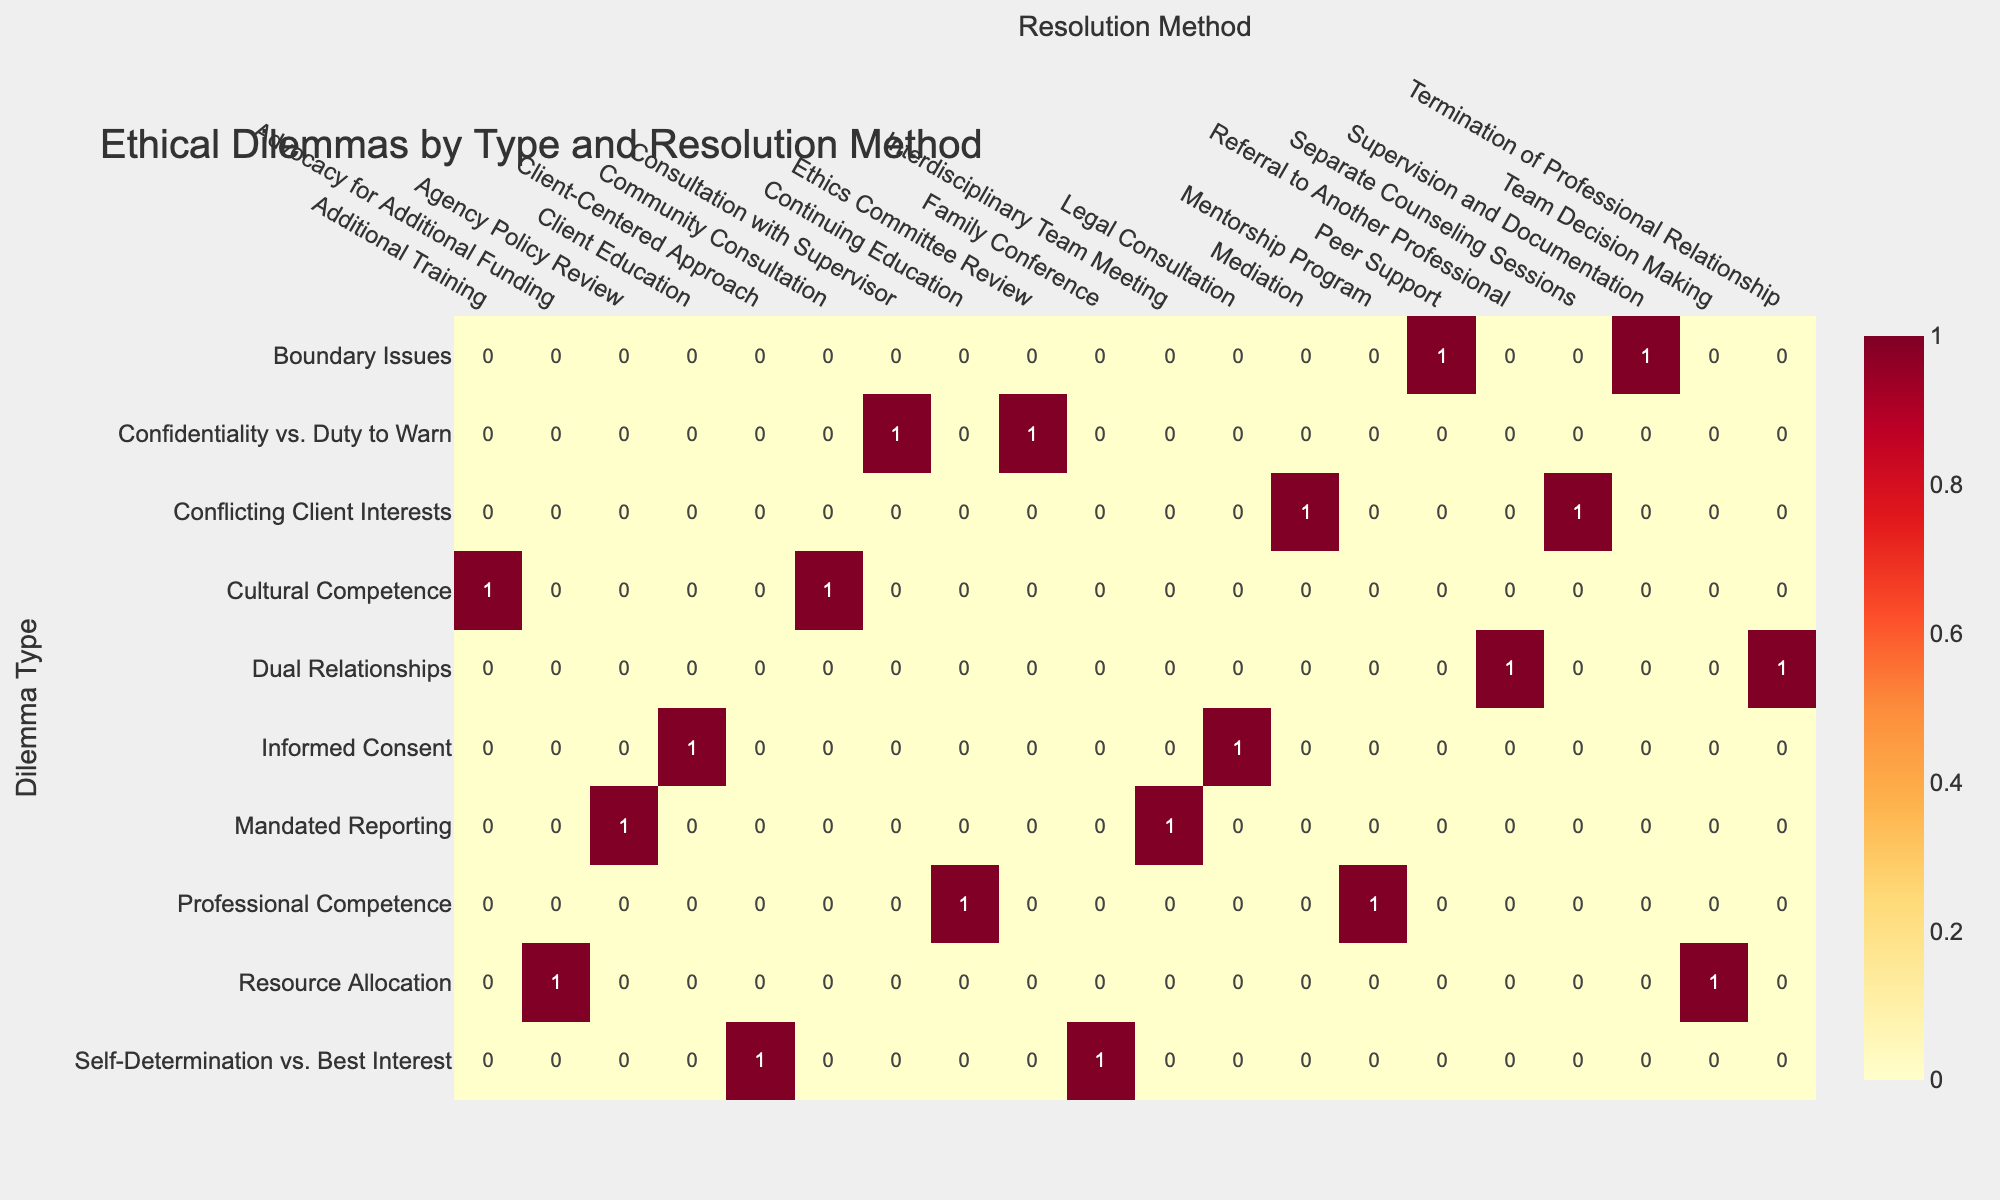What is the most common resolution method for dealing with confidentiality dilemmas? By reviewing the 'Confidentiality vs. Duty to Warn' row in the table, I can see that there are two resolution methods associated with it: 'Consultation with Supervisor' and 'Ethics Committee Review.' Counting the occurrences, 'Consultation with Supervisor' appears once and 'Ethics Committee Review' appears once. Hence, both methods have the same frequency for this dilemma type.
Answer: Both methods are equally common How many dilemmas were resolved through 'Referral to Another Professional'? Checking the table, I find the resolution method 'Referral to Another Professional' under the 'Dual Relationships' dilemma type. It is listed once under case number SW-2023-002, indicating that only one dilemma was resolved using this method.
Answer: One dilemma was resolved Which dilemma type has the highest number of resolved cases? I need to compare the counts of case numbers for each dilemma type. The counts are: 'Confidentiality vs. Duty to Warn' (2 cases), 'Dual Relationships' (2 cases), 'Resource Allocation' (2 cases), 'Self-Determination vs. Best Interest' (2 cases), 'Cultural Competence' (2 cases), 'Informed Consent' (2 cases), 'Boundary Issues' (2 cases), 'Mandated Reporting' (2 cases), 'Conflicting Client Interests' (2 cases), and 'Professional Competence' (2 cases). This indicates that all dilemma types have the same highest occurrence of 2 cases each.
Answer: All types are equally frequent Did any resolution method specify a client age group under 'Child'? Looking through the cases categorized under the 'Child' age group, I see that 'Mandated Reporting' was resolved through 'Agency Policy Review' and 'Resource Allocation' utilized 'Advocacy for Additional Funding.' Thus, there are two resulting cases. Therefore, there were resolution methods specified for 'Child.'
Answer: Yes What is the difference in the number of resolutions between 'Team Decision Making' and 'Consultation with Supervisor'? I check 'Team Decision Making' under 'Resource Allocation,' which has one entry, and 'Consultation with Supervisor' under 'Confidentiality vs. Duty to Warn,' which also has one entry. Since both resolution methods have one case, the difference is 0.
Answer: The difference is 0 